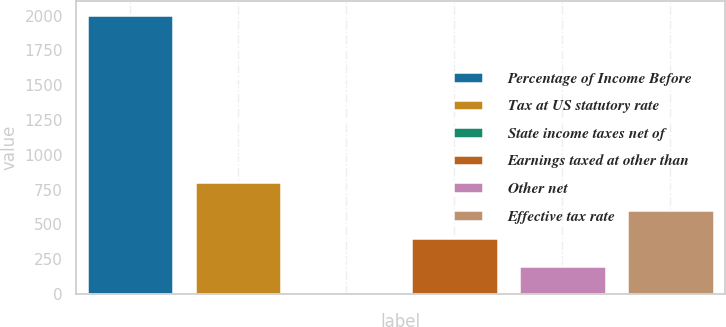Convert chart to OTSL. <chart><loc_0><loc_0><loc_500><loc_500><bar_chart><fcel>Percentage of Income Before<fcel>Tax at US statutory rate<fcel>State income taxes net of<fcel>Earnings taxed at other than<fcel>Other net<fcel>Effective tax rate<nl><fcel>2002<fcel>801.16<fcel>0.6<fcel>400.88<fcel>200.74<fcel>601.02<nl></chart> 